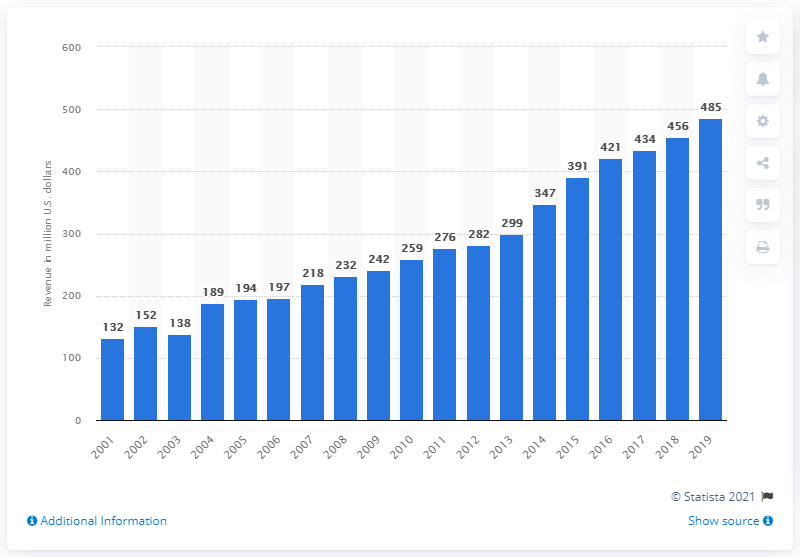Mention a couple of crucial points in this snapshot. The revenue of the Green Bay Packers in 2019 was approximately 485 million dollars. 